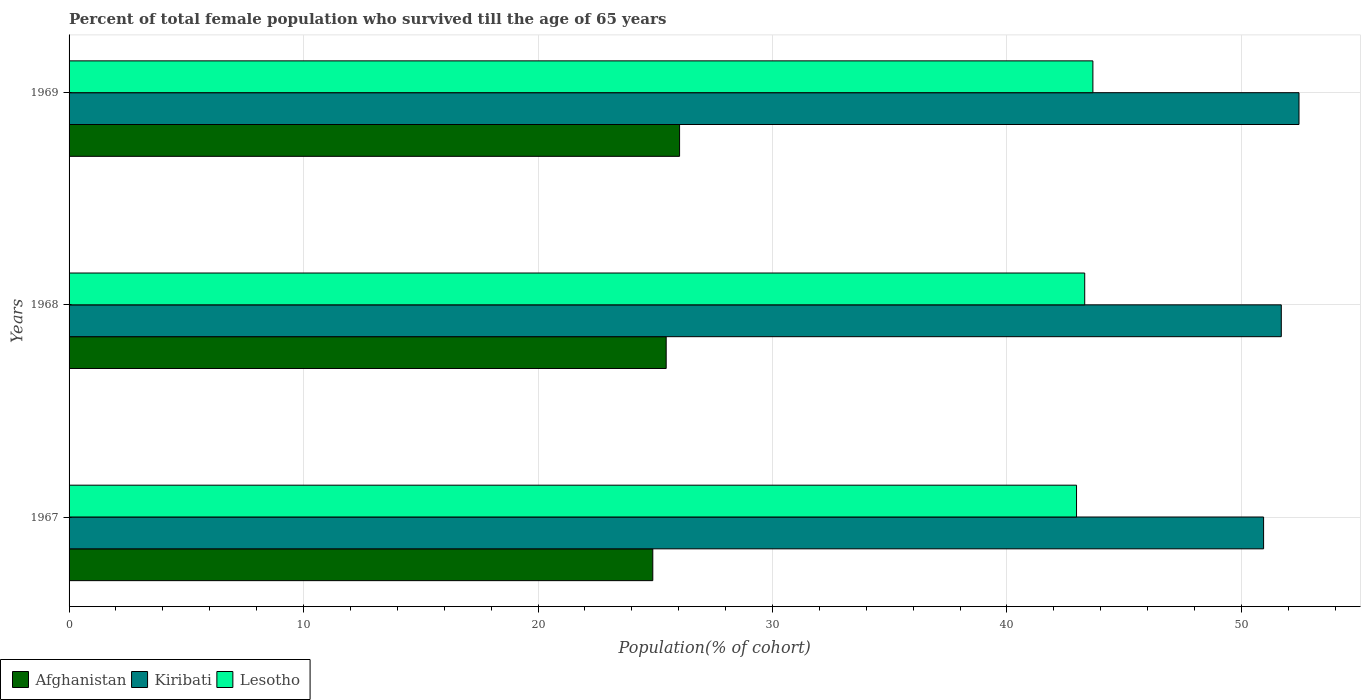How many different coloured bars are there?
Provide a short and direct response. 3. How many groups of bars are there?
Provide a succinct answer. 3. Are the number of bars per tick equal to the number of legend labels?
Your answer should be very brief. Yes. Are the number of bars on each tick of the Y-axis equal?
Offer a very short reply. Yes. How many bars are there on the 3rd tick from the top?
Your answer should be very brief. 3. How many bars are there on the 2nd tick from the bottom?
Provide a succinct answer. 3. What is the label of the 1st group of bars from the top?
Ensure brevity in your answer.  1969. In how many cases, is the number of bars for a given year not equal to the number of legend labels?
Keep it short and to the point. 0. What is the percentage of total female population who survived till the age of 65 years in Lesotho in 1967?
Make the answer very short. 42.97. Across all years, what is the maximum percentage of total female population who survived till the age of 65 years in Afghanistan?
Offer a terse response. 26.04. Across all years, what is the minimum percentage of total female population who survived till the age of 65 years in Lesotho?
Provide a short and direct response. 42.97. In which year was the percentage of total female population who survived till the age of 65 years in Afghanistan maximum?
Ensure brevity in your answer.  1969. In which year was the percentage of total female population who survived till the age of 65 years in Lesotho minimum?
Offer a very short reply. 1967. What is the total percentage of total female population who survived till the age of 65 years in Kiribati in the graph?
Offer a terse response. 155.1. What is the difference between the percentage of total female population who survived till the age of 65 years in Kiribati in 1967 and that in 1968?
Ensure brevity in your answer.  -0.76. What is the difference between the percentage of total female population who survived till the age of 65 years in Kiribati in 1967 and the percentage of total female population who survived till the age of 65 years in Afghanistan in 1969?
Provide a short and direct response. 24.91. What is the average percentage of total female population who survived till the age of 65 years in Kiribati per year?
Provide a short and direct response. 51.7. In the year 1968, what is the difference between the percentage of total female population who survived till the age of 65 years in Kiribati and percentage of total female population who survived till the age of 65 years in Lesotho?
Provide a short and direct response. 8.38. What is the ratio of the percentage of total female population who survived till the age of 65 years in Afghanistan in 1967 to that in 1968?
Make the answer very short. 0.98. Is the percentage of total female population who survived till the age of 65 years in Kiribati in 1967 less than that in 1968?
Your answer should be compact. Yes. What is the difference between the highest and the second highest percentage of total female population who survived till the age of 65 years in Lesotho?
Make the answer very short. 0.35. What is the difference between the highest and the lowest percentage of total female population who survived till the age of 65 years in Kiribati?
Make the answer very short. 1.51. In how many years, is the percentage of total female population who survived till the age of 65 years in Kiribati greater than the average percentage of total female population who survived till the age of 65 years in Kiribati taken over all years?
Give a very brief answer. 2. What does the 2nd bar from the top in 1967 represents?
Ensure brevity in your answer.  Kiribati. What does the 3rd bar from the bottom in 1968 represents?
Provide a short and direct response. Lesotho. Is it the case that in every year, the sum of the percentage of total female population who survived till the age of 65 years in Lesotho and percentage of total female population who survived till the age of 65 years in Afghanistan is greater than the percentage of total female population who survived till the age of 65 years in Kiribati?
Keep it short and to the point. Yes. Are all the bars in the graph horizontal?
Offer a terse response. Yes. Does the graph contain any zero values?
Provide a succinct answer. No. Does the graph contain grids?
Offer a terse response. Yes. Where does the legend appear in the graph?
Your response must be concise. Bottom left. How are the legend labels stacked?
Give a very brief answer. Horizontal. What is the title of the graph?
Your answer should be compact. Percent of total female population who survived till the age of 65 years. Does "Somalia" appear as one of the legend labels in the graph?
Give a very brief answer. No. What is the label or title of the X-axis?
Your answer should be compact. Population(% of cohort). What is the label or title of the Y-axis?
Give a very brief answer. Years. What is the Population(% of cohort) of Afghanistan in 1967?
Ensure brevity in your answer.  24.89. What is the Population(% of cohort) in Kiribati in 1967?
Your response must be concise. 50.94. What is the Population(% of cohort) in Lesotho in 1967?
Provide a short and direct response. 42.97. What is the Population(% of cohort) in Afghanistan in 1968?
Provide a succinct answer. 25.47. What is the Population(% of cohort) in Kiribati in 1968?
Provide a succinct answer. 51.7. What is the Population(% of cohort) of Lesotho in 1968?
Make the answer very short. 43.31. What is the Population(% of cohort) of Afghanistan in 1969?
Offer a terse response. 26.04. What is the Population(% of cohort) in Kiribati in 1969?
Ensure brevity in your answer.  52.45. What is the Population(% of cohort) of Lesotho in 1969?
Offer a terse response. 43.66. Across all years, what is the maximum Population(% of cohort) of Afghanistan?
Provide a short and direct response. 26.04. Across all years, what is the maximum Population(% of cohort) in Kiribati?
Provide a short and direct response. 52.45. Across all years, what is the maximum Population(% of cohort) of Lesotho?
Give a very brief answer. 43.66. Across all years, what is the minimum Population(% of cohort) of Afghanistan?
Offer a terse response. 24.89. Across all years, what is the minimum Population(% of cohort) of Kiribati?
Offer a very short reply. 50.94. Across all years, what is the minimum Population(% of cohort) in Lesotho?
Give a very brief answer. 42.97. What is the total Population(% of cohort) in Afghanistan in the graph?
Ensure brevity in your answer.  76.4. What is the total Population(% of cohort) in Kiribati in the graph?
Make the answer very short. 155.1. What is the total Population(% of cohort) of Lesotho in the graph?
Provide a short and direct response. 129.94. What is the difference between the Population(% of cohort) in Afghanistan in 1967 and that in 1968?
Ensure brevity in your answer.  -0.57. What is the difference between the Population(% of cohort) of Kiribati in 1967 and that in 1968?
Your answer should be very brief. -0.76. What is the difference between the Population(% of cohort) in Lesotho in 1967 and that in 1968?
Offer a very short reply. -0.35. What is the difference between the Population(% of cohort) in Afghanistan in 1967 and that in 1969?
Provide a succinct answer. -1.14. What is the difference between the Population(% of cohort) of Kiribati in 1967 and that in 1969?
Provide a succinct answer. -1.51. What is the difference between the Population(% of cohort) of Lesotho in 1967 and that in 1969?
Offer a very short reply. -0.7. What is the difference between the Population(% of cohort) in Afghanistan in 1968 and that in 1969?
Provide a short and direct response. -0.57. What is the difference between the Population(% of cohort) in Kiribati in 1968 and that in 1969?
Ensure brevity in your answer.  -0.76. What is the difference between the Population(% of cohort) of Lesotho in 1968 and that in 1969?
Your answer should be very brief. -0.35. What is the difference between the Population(% of cohort) of Afghanistan in 1967 and the Population(% of cohort) of Kiribati in 1968?
Your answer should be very brief. -26.8. What is the difference between the Population(% of cohort) of Afghanistan in 1967 and the Population(% of cohort) of Lesotho in 1968?
Make the answer very short. -18.42. What is the difference between the Population(% of cohort) in Kiribati in 1967 and the Population(% of cohort) in Lesotho in 1968?
Offer a terse response. 7.63. What is the difference between the Population(% of cohort) in Afghanistan in 1967 and the Population(% of cohort) in Kiribati in 1969?
Your response must be concise. -27.56. What is the difference between the Population(% of cohort) of Afghanistan in 1967 and the Population(% of cohort) of Lesotho in 1969?
Provide a succinct answer. -18.77. What is the difference between the Population(% of cohort) of Kiribati in 1967 and the Population(% of cohort) of Lesotho in 1969?
Provide a short and direct response. 7.28. What is the difference between the Population(% of cohort) of Afghanistan in 1968 and the Population(% of cohort) of Kiribati in 1969?
Your answer should be very brief. -26.99. What is the difference between the Population(% of cohort) of Afghanistan in 1968 and the Population(% of cohort) of Lesotho in 1969?
Give a very brief answer. -18.2. What is the difference between the Population(% of cohort) in Kiribati in 1968 and the Population(% of cohort) in Lesotho in 1969?
Offer a terse response. 8.03. What is the average Population(% of cohort) of Afghanistan per year?
Your response must be concise. 25.47. What is the average Population(% of cohort) in Kiribati per year?
Your response must be concise. 51.7. What is the average Population(% of cohort) in Lesotho per year?
Your answer should be very brief. 43.31. In the year 1967, what is the difference between the Population(% of cohort) in Afghanistan and Population(% of cohort) in Kiribati?
Offer a very short reply. -26.05. In the year 1967, what is the difference between the Population(% of cohort) of Afghanistan and Population(% of cohort) of Lesotho?
Make the answer very short. -18.07. In the year 1967, what is the difference between the Population(% of cohort) in Kiribati and Population(% of cohort) in Lesotho?
Make the answer very short. 7.98. In the year 1968, what is the difference between the Population(% of cohort) of Afghanistan and Population(% of cohort) of Kiribati?
Make the answer very short. -26.23. In the year 1968, what is the difference between the Population(% of cohort) of Afghanistan and Population(% of cohort) of Lesotho?
Offer a terse response. -17.85. In the year 1968, what is the difference between the Population(% of cohort) of Kiribati and Population(% of cohort) of Lesotho?
Your response must be concise. 8.38. In the year 1969, what is the difference between the Population(% of cohort) of Afghanistan and Population(% of cohort) of Kiribati?
Keep it short and to the point. -26.42. In the year 1969, what is the difference between the Population(% of cohort) of Afghanistan and Population(% of cohort) of Lesotho?
Your answer should be compact. -17.63. In the year 1969, what is the difference between the Population(% of cohort) of Kiribati and Population(% of cohort) of Lesotho?
Ensure brevity in your answer.  8.79. What is the ratio of the Population(% of cohort) of Afghanistan in 1967 to that in 1968?
Your response must be concise. 0.98. What is the ratio of the Population(% of cohort) in Kiribati in 1967 to that in 1968?
Your answer should be compact. 0.99. What is the ratio of the Population(% of cohort) of Lesotho in 1967 to that in 1968?
Keep it short and to the point. 0.99. What is the ratio of the Population(% of cohort) in Afghanistan in 1967 to that in 1969?
Keep it short and to the point. 0.96. What is the ratio of the Population(% of cohort) in Kiribati in 1967 to that in 1969?
Your answer should be very brief. 0.97. What is the ratio of the Population(% of cohort) in Afghanistan in 1968 to that in 1969?
Provide a succinct answer. 0.98. What is the ratio of the Population(% of cohort) in Kiribati in 1968 to that in 1969?
Your answer should be very brief. 0.99. What is the difference between the highest and the second highest Population(% of cohort) of Afghanistan?
Your response must be concise. 0.57. What is the difference between the highest and the second highest Population(% of cohort) in Kiribati?
Offer a very short reply. 0.76. What is the difference between the highest and the second highest Population(% of cohort) of Lesotho?
Offer a terse response. 0.35. What is the difference between the highest and the lowest Population(% of cohort) of Afghanistan?
Your answer should be compact. 1.14. What is the difference between the highest and the lowest Population(% of cohort) in Kiribati?
Your answer should be very brief. 1.51. What is the difference between the highest and the lowest Population(% of cohort) of Lesotho?
Provide a succinct answer. 0.7. 